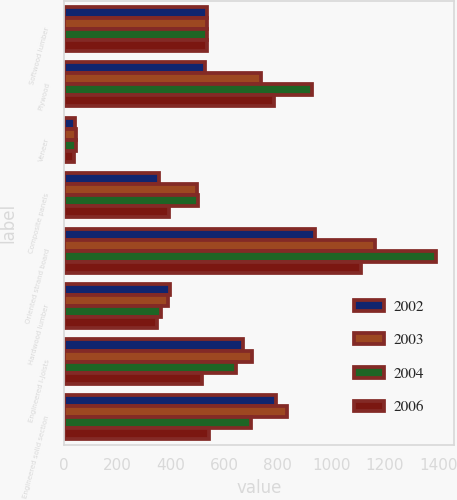<chart> <loc_0><loc_0><loc_500><loc_500><stacked_bar_chart><ecel><fcel>Softwood lumber<fcel>Plywood<fcel>Veneer<fcel>Composite panels<fcel>Oriented strand board<fcel>Hardwood lumber<fcel>Engineered I-Joists<fcel>Engineered solid section<nl><fcel>2002<fcel>535.5<fcel>529<fcel>42<fcel>357<fcel>939<fcel>398<fcel>670<fcel>794<nl><fcel>2003<fcel>535.5<fcel>735<fcel>44<fcel>497<fcel>1164<fcel>390<fcel>704<fcel>833<nl><fcel>2004<fcel>535.5<fcel>929<fcel>44<fcel>501<fcel>1390<fcel>365<fcel>645<fcel>701<nl><fcel>2006<fcel>535.5<fcel>784<fcel>39<fcel>393<fcel>1109<fcel>350<fcel>517<fcel>542<nl></chart> 